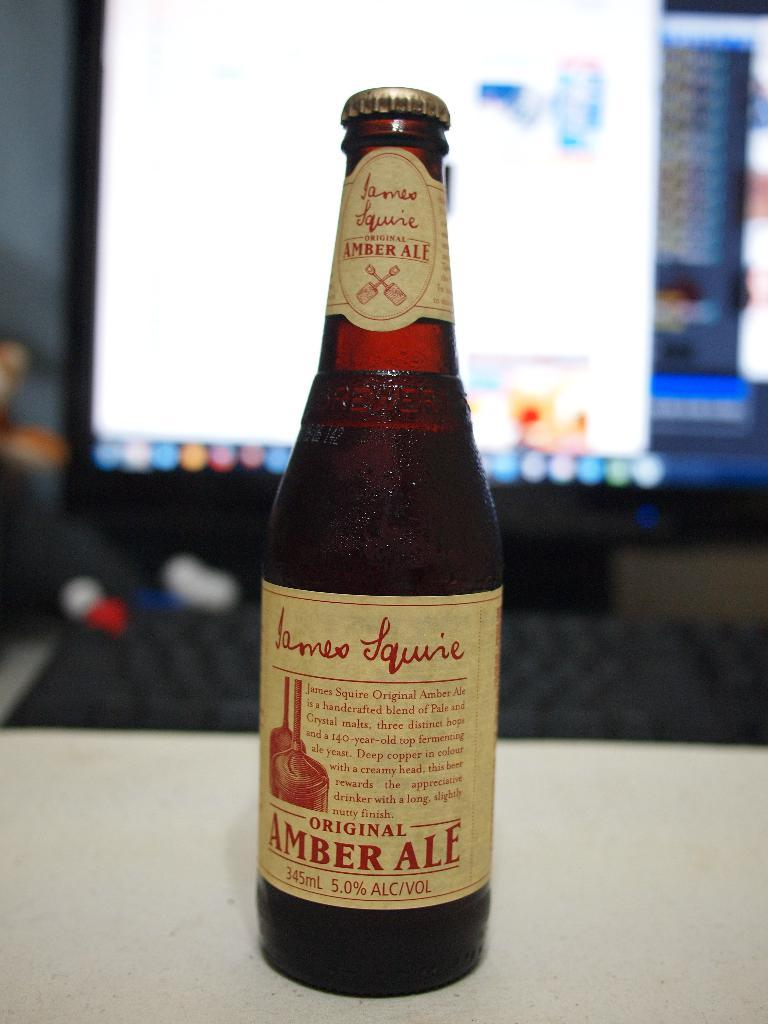Provide a one-sentence caption for the provided image. A bottle with a label stating Original Amber Ale. 